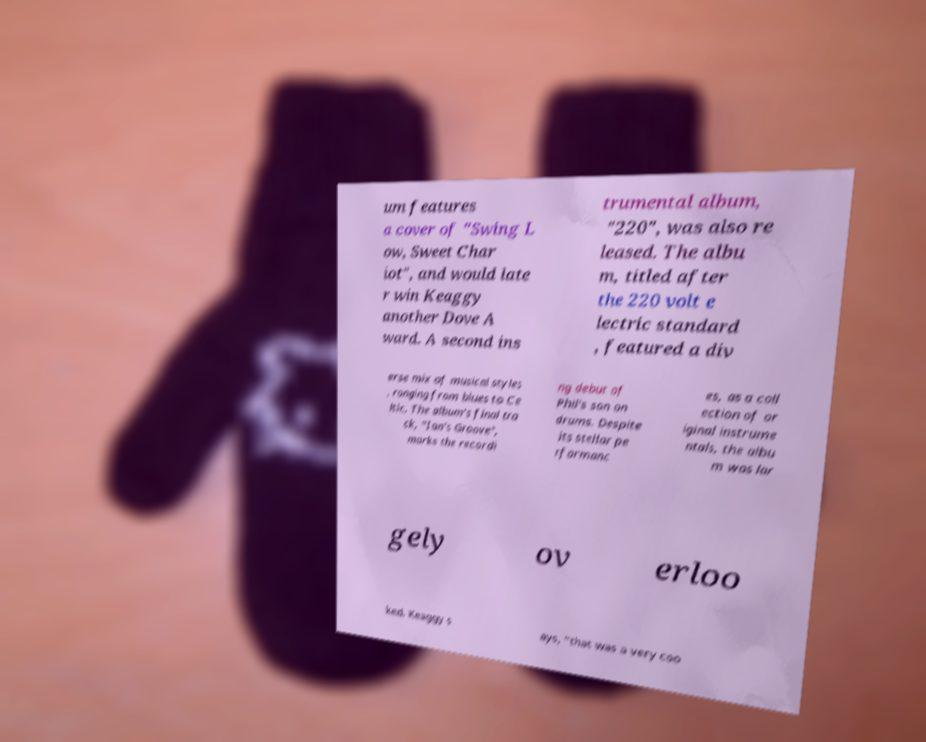What messages or text are displayed in this image? I need them in a readable, typed format. um features a cover of "Swing L ow, Sweet Char iot", and would late r win Keaggy another Dove A ward. A second ins trumental album, "220", was also re leased. The albu m, titled after the 220 volt e lectric standard , featured a div erse mix of musical styles , ranging from blues to Ce ltic. The album's final tra ck, "Ian's Groove", marks the recordi ng debut of Phil's son on drums. Despite its stellar pe rformanc es, as a coll ection of or iginal instrume ntals, the albu m was lar gely ov erloo ked. Keaggy s ays, "that was a very coo 